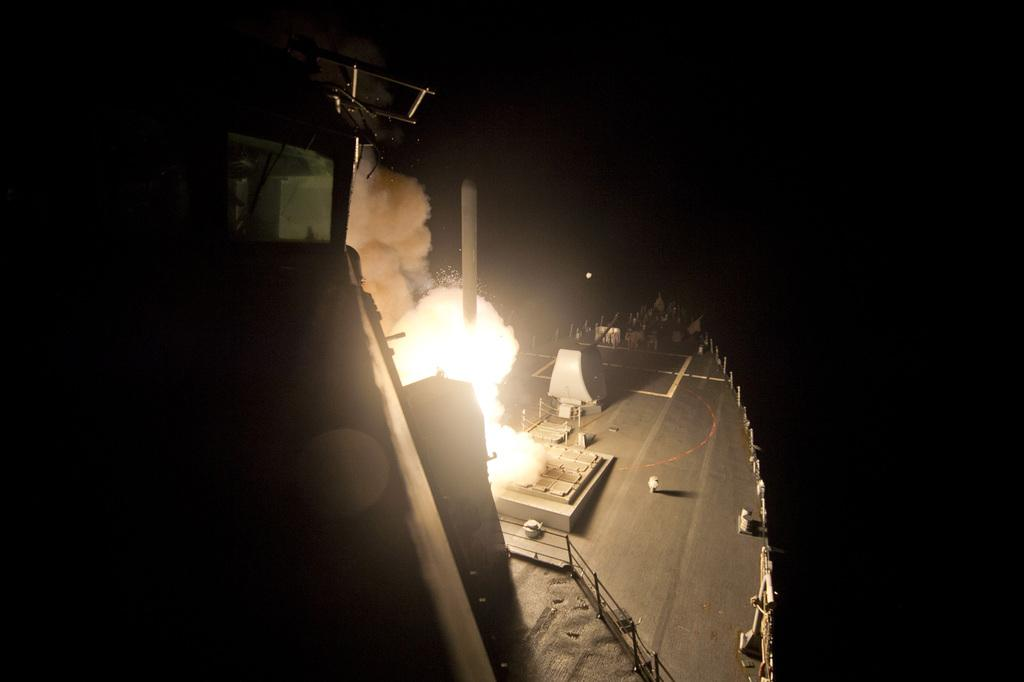What is the main subject of the image? The main subject of the image is a ship. What is happening to the ship in the image? There is a fire in the picture, and smoke is coming out from the fire. How would you describe the lighting in the image? The area around the ship is dark. What type of celery is being used to put out the fire in the image? There is no celery present in the image, and it is not being used to put out the fire. 